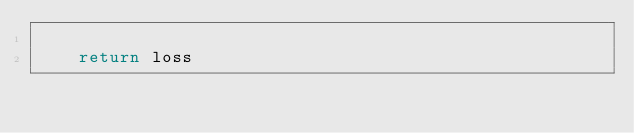Convert code to text. <code><loc_0><loc_0><loc_500><loc_500><_Python_>
    return loss

</code> 